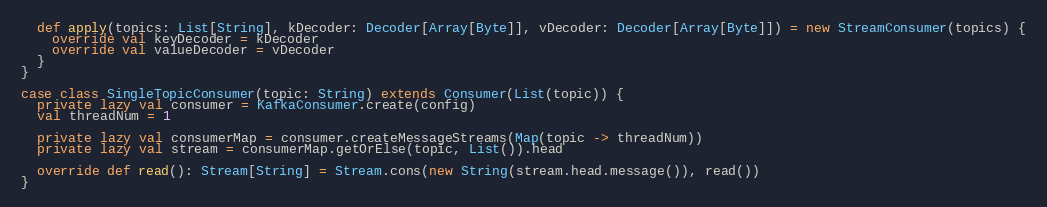<code> <loc_0><loc_0><loc_500><loc_500><_Scala_>  def apply(topics: List[String], kDecoder: Decoder[Array[Byte]], vDecoder: Decoder[Array[Byte]]) = new StreamConsumer(topics) {
    override val keyDecoder = kDecoder
    override val valueDecoder = vDecoder
  }
}

case class SingleTopicConsumer(topic: String) extends Consumer(List(topic)) {
  private lazy val consumer = KafkaConsumer.create(config)
  val threadNum = 1

  private lazy val consumerMap = consumer.createMessageStreams(Map(topic -> threadNum))
  private lazy val stream = consumerMap.getOrElse(topic, List()).head

  override def read(): Stream[String] = Stream.cons(new String(stream.head.message()), read())
}</code> 